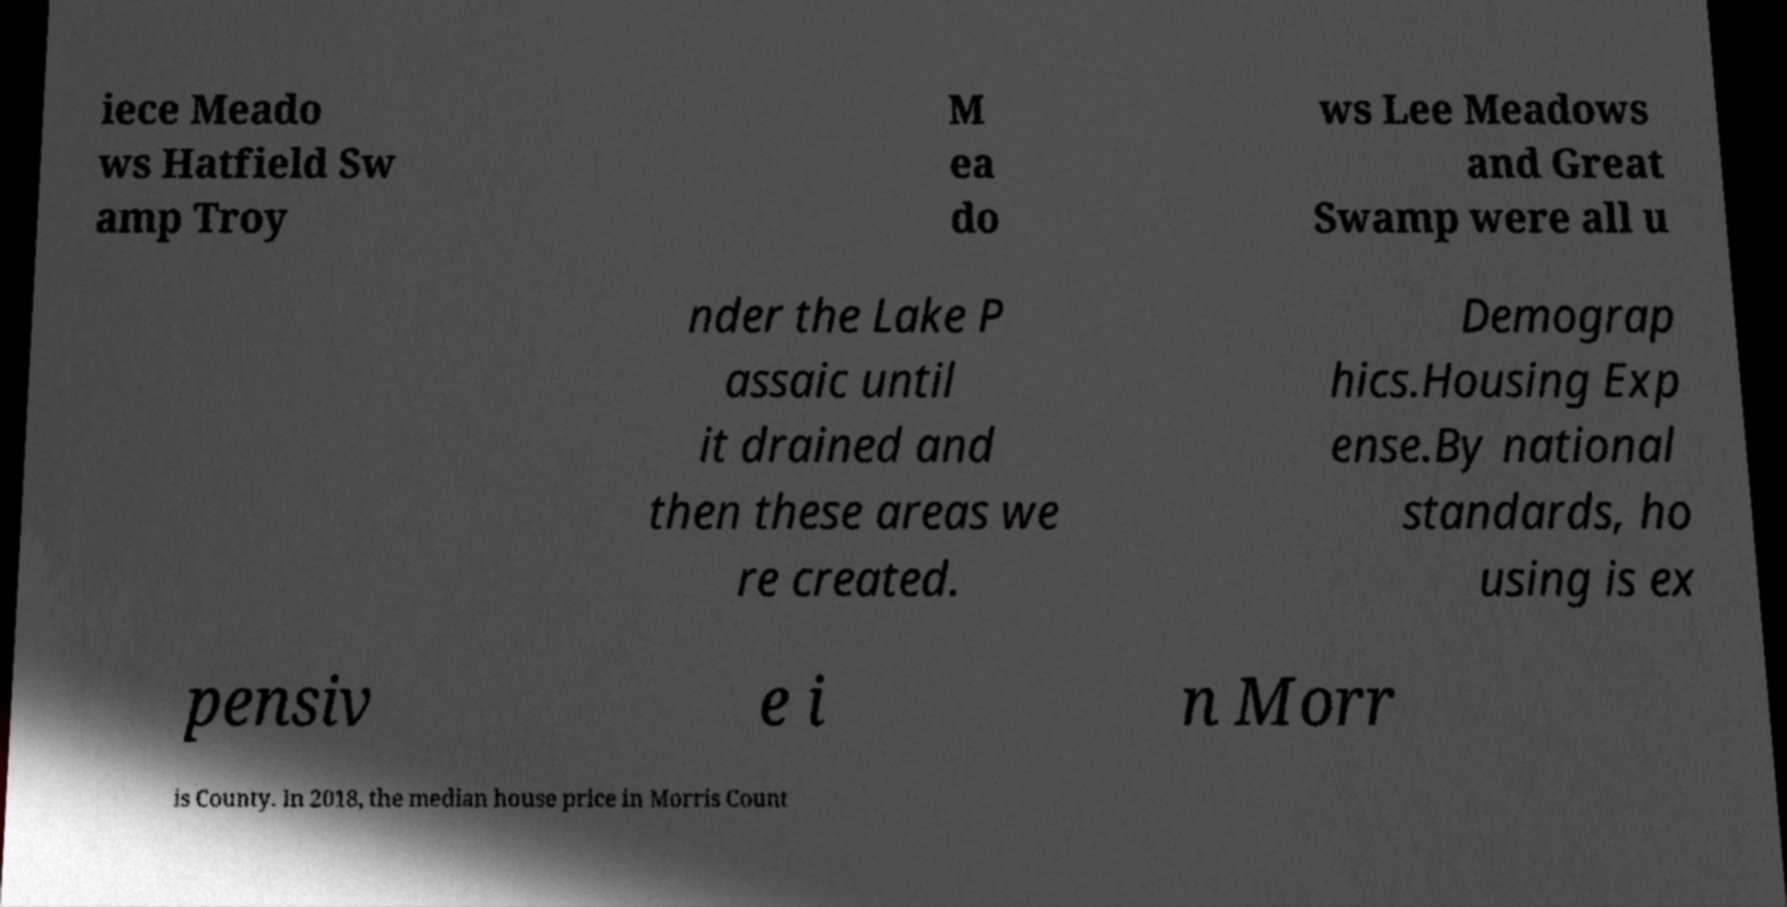Please identify and transcribe the text found in this image. iece Meado ws Hatfield Sw amp Troy M ea do ws Lee Meadows and Great Swamp were all u nder the Lake P assaic until it drained and then these areas we re created. Demograp hics.Housing Exp ense.By national standards, ho using is ex pensiv e i n Morr is County. In 2018, the median house price in Morris Count 